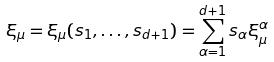Convert formula to latex. <formula><loc_0><loc_0><loc_500><loc_500>\xi _ { \mu } = \xi _ { \mu } ( s _ { 1 } , \dots , s _ { d + 1 } ) = \sum _ { \alpha = 1 } ^ { d + 1 } s _ { \alpha } \xi _ { \mu } ^ { \alpha }</formula> 